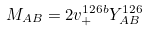<formula> <loc_0><loc_0><loc_500><loc_500>M _ { A B } = 2 v _ { + } ^ { 1 2 6 b } Y _ { A B } ^ { 1 2 6 }</formula> 